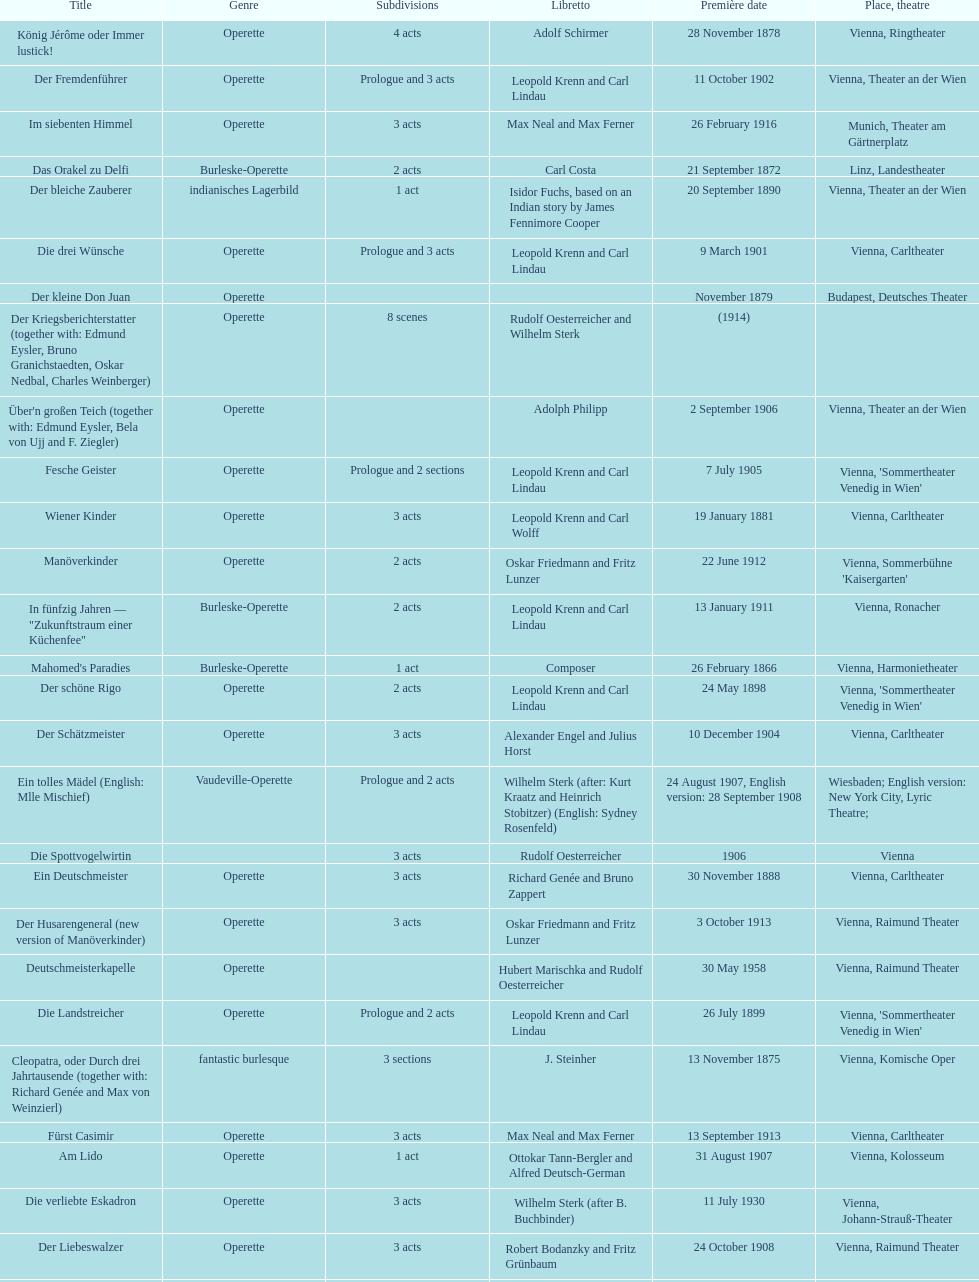What was the year of the last title? 1958. 